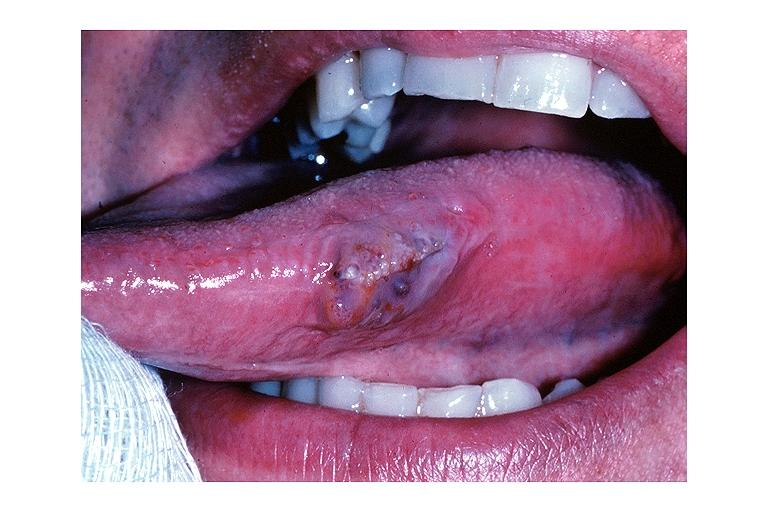does adenosis and ischemia show lymphangioma?
Answer the question using a single word or phrase. No 